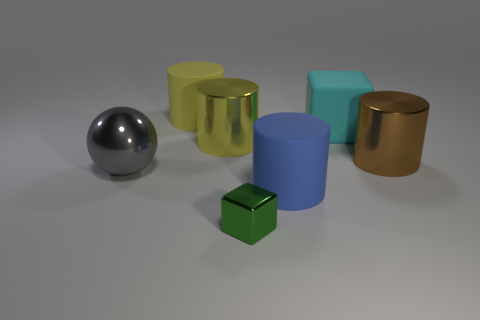There is a gray object that is the same size as the blue rubber object; what is its material?
Provide a short and direct response. Metal. What number of matte things are tiny cyan cylinders or brown objects?
Your response must be concise. 0. Is the number of cyan matte cubes in front of the metal sphere less than the number of yellow matte blocks?
Provide a succinct answer. No. There is a rubber thing that is on the right side of the big rubber cylinder right of the cube in front of the big sphere; what is its shape?
Keep it short and to the point. Cube. Is the number of blue rubber balls greater than the number of big rubber cylinders?
Provide a short and direct response. No. How many other things are there of the same material as the large gray object?
Provide a short and direct response. 3. How many things are either large gray metallic spheres or matte objects in front of the yellow matte object?
Offer a terse response. 3. Are there fewer green objects than objects?
Your response must be concise. Yes. There is a matte object to the left of the cube that is to the left of the big matte cylinder on the right side of the large yellow matte object; what is its color?
Provide a short and direct response. Yellow. Does the large cyan cube have the same material as the large blue object?
Your answer should be compact. Yes. 